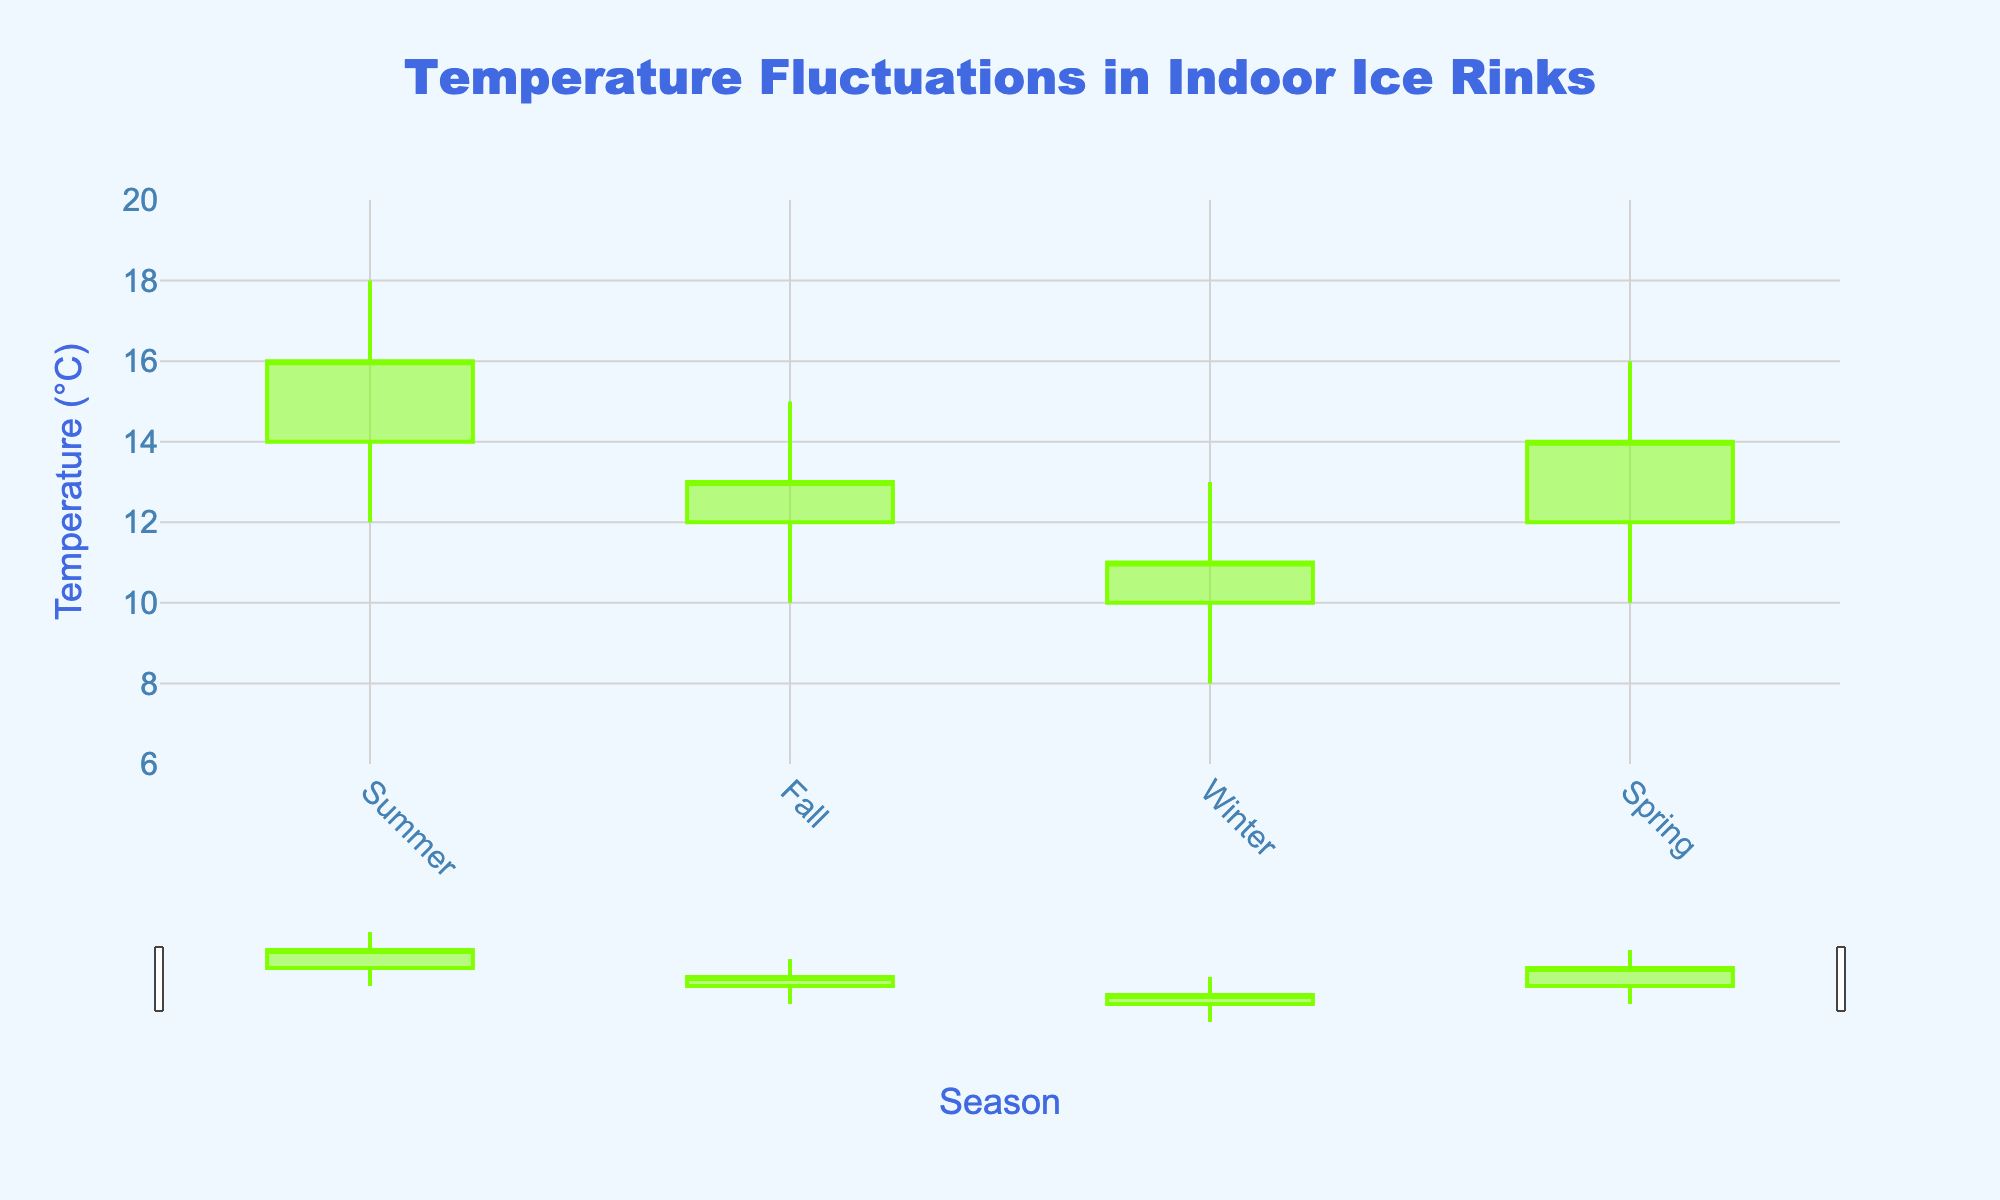What's the title of the chart? The title is located at the top center of the chart.
Answer: Temperature Fluctuations in Indoor Ice Rinks What does the y-axis represent? The y-axis label indicates it represents temperature in degrees Celsius (°C).
Answer: Temperature (°C) Which season has the highest temperature recorded? In the chart, the highest value on the y-axis occurs in the summer, which is marked at 18°C.
Answer: Summer What's the range of temperatures in winter? The low value for winter is 8°C, and the high value is 13°C. So, the range is 13 - 8 = 5°C.
Answer: 5°C Which season shows the greatest temperature fluctuation? To find the greatest fluctuation, we subtract the low value from the high value for each season: Summer (18-12=6), Fall (15-10=5), Winter (13-8=5), Spring (16-10=6). Summer and Spring both have the greatest fluctuation of 6°C.
Answer: Summer and Spring Are there any seasons where the closing temperature is higher than the opening temperature? By comparing the open and close values for each season: Summer (14 < 16), Fall (12 < 13), Winter (10 < 11), Spring (12 < 14); all seasons have closing temperatures higher than their opening temperatures.
Answer: Yes, all seasons What is the average high temperature across all seasons? The high temperatures are 18 (Summer), 15 (Fall), 13 (Winter), and 16 (Spring). The sum is 18 + 15 + 13 + 16 = 62. Dividing by 4, the average is 62 / 4 = 15.5°C.
Answer: 15.5°C Which season has the smallest temperature decrease from open to close? By calculating the difference for each season: Summer (16 - 14 = 2), Fall (13 - 12 = 1), Winter (11 - 10 = 1), Spring (14 - 12 = 2). Fall and Winter have the smallest decrease of 1°C.
Answer: Fall and Winter What's the median closing temperature across all seasons? The closing temperatures are 16 (Summer), 13 (Fall), 11 (Winter), and 14 (Spring). Arranging these in order: 11, 13, 14, 16. The median is the average of the two middle numbers (13 and 14), so (13 + 14) / 2 = 13.5°C.
Answer: 13.5°C Which season shows a closing temperature 2°C less than its opening temperature? By examining the differences, Spring has 12 as the opening and 14 as the close, resulting in a +2°C difference. All seasons show temperature increases from open to close.
Answer: None 